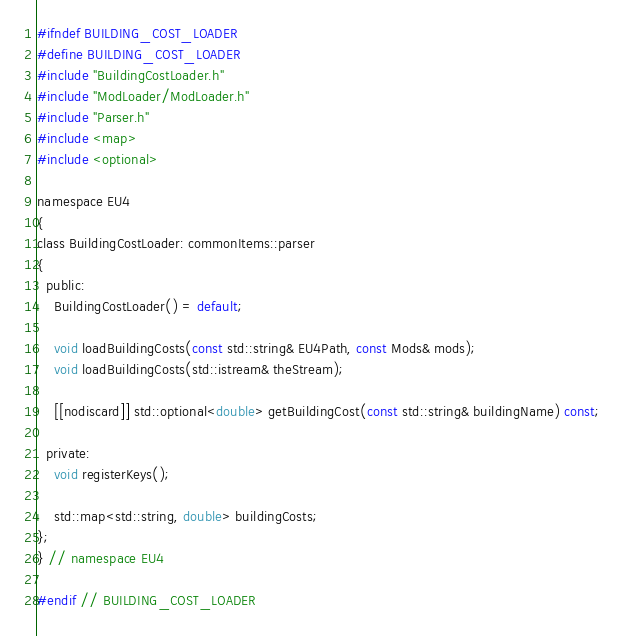Convert code to text. <code><loc_0><loc_0><loc_500><loc_500><_C_>#ifndef BUILDING_COST_LOADER
#define BUILDING_COST_LOADER
#include "BuildingCostLoader.h"
#include "ModLoader/ModLoader.h"
#include "Parser.h"
#include <map>
#include <optional>

namespace EU4
{
class BuildingCostLoader: commonItems::parser
{
  public:
	BuildingCostLoader() = default;

	void loadBuildingCosts(const std::string& EU4Path, const Mods& mods);
	void loadBuildingCosts(std::istream& theStream);

	[[nodiscard]] std::optional<double> getBuildingCost(const std::string& buildingName) const;

  private:
	void registerKeys();

	std::map<std::string, double> buildingCosts;
};
} // namespace EU4

#endif // BUILDING_COST_LOADER</code> 